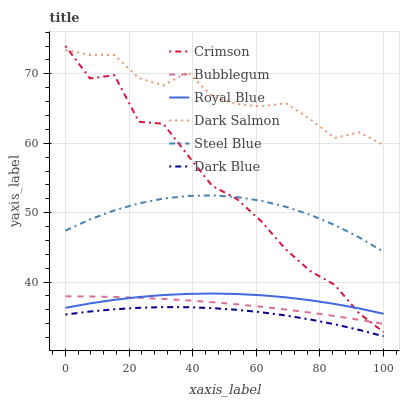Does Dark Blue have the minimum area under the curve?
Answer yes or no. Yes. Does Dark Salmon have the maximum area under the curve?
Answer yes or no. Yes. Does Bubblegum have the minimum area under the curve?
Answer yes or no. No. Does Bubblegum have the maximum area under the curve?
Answer yes or no. No. Is Bubblegum the smoothest?
Answer yes or no. Yes. Is Crimson the roughest?
Answer yes or no. Yes. Is Dark Salmon the smoothest?
Answer yes or no. No. Is Dark Salmon the roughest?
Answer yes or no. No. Does Dark Blue have the lowest value?
Answer yes or no. Yes. Does Bubblegum have the lowest value?
Answer yes or no. No. Does Crimson have the highest value?
Answer yes or no. Yes. Does Dark Salmon have the highest value?
Answer yes or no. No. Is Royal Blue less than Steel Blue?
Answer yes or no. Yes. Is Dark Salmon greater than Bubblegum?
Answer yes or no. Yes. Does Crimson intersect Bubblegum?
Answer yes or no. Yes. Is Crimson less than Bubblegum?
Answer yes or no. No. Is Crimson greater than Bubblegum?
Answer yes or no. No. Does Royal Blue intersect Steel Blue?
Answer yes or no. No. 